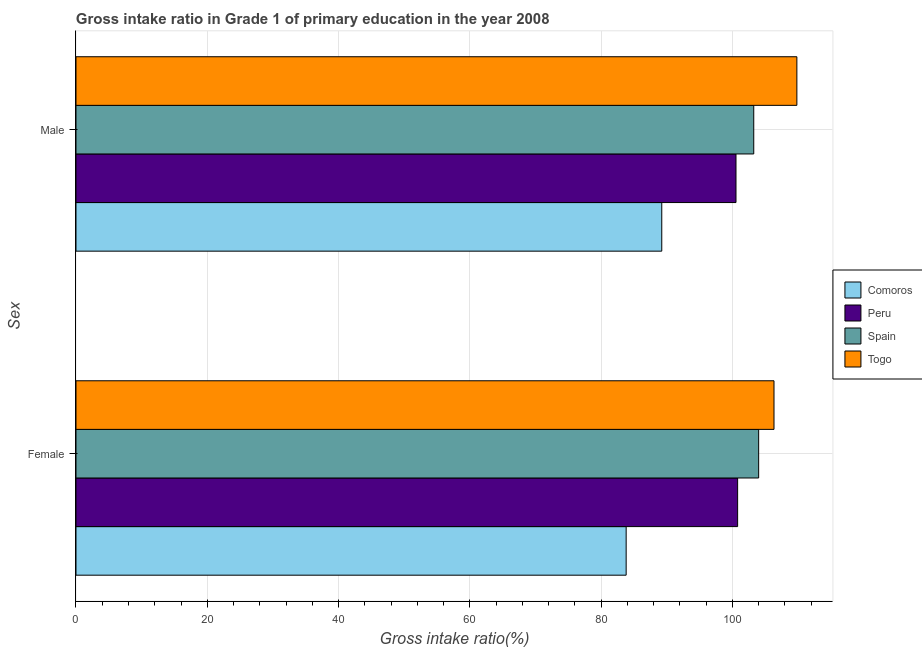How many bars are there on the 1st tick from the bottom?
Provide a short and direct response. 4. What is the gross intake ratio(female) in Spain?
Your answer should be very brief. 104.01. Across all countries, what is the maximum gross intake ratio(female)?
Offer a very short reply. 106.35. Across all countries, what is the minimum gross intake ratio(female)?
Your response must be concise. 83.82. In which country was the gross intake ratio(female) maximum?
Provide a short and direct response. Togo. In which country was the gross intake ratio(female) minimum?
Offer a terse response. Comoros. What is the total gross intake ratio(female) in the graph?
Keep it short and to the point. 394.97. What is the difference between the gross intake ratio(male) in Peru and that in Spain?
Your answer should be compact. -2.71. What is the difference between the gross intake ratio(male) in Peru and the gross intake ratio(female) in Togo?
Make the answer very short. -5.79. What is the average gross intake ratio(male) per country?
Provide a succinct answer. 100.72. What is the difference between the gross intake ratio(male) and gross intake ratio(female) in Peru?
Keep it short and to the point. -0.25. What is the ratio of the gross intake ratio(male) in Comoros to that in Togo?
Give a very brief answer. 0.81. Is the gross intake ratio(male) in Comoros less than that in Peru?
Your response must be concise. Yes. In how many countries, is the gross intake ratio(male) greater than the average gross intake ratio(male) taken over all countries?
Your answer should be compact. 2. What does the 1st bar from the bottom in Male represents?
Keep it short and to the point. Comoros. How many bars are there?
Provide a short and direct response. 8. Are all the bars in the graph horizontal?
Make the answer very short. Yes. How many countries are there in the graph?
Make the answer very short. 4. Does the graph contain any zero values?
Ensure brevity in your answer.  No. Does the graph contain grids?
Offer a terse response. Yes. How many legend labels are there?
Keep it short and to the point. 4. What is the title of the graph?
Offer a very short reply. Gross intake ratio in Grade 1 of primary education in the year 2008. What is the label or title of the X-axis?
Ensure brevity in your answer.  Gross intake ratio(%). What is the label or title of the Y-axis?
Provide a succinct answer. Sex. What is the Gross intake ratio(%) in Comoros in Female?
Your answer should be very brief. 83.82. What is the Gross intake ratio(%) of Peru in Female?
Provide a short and direct response. 100.8. What is the Gross intake ratio(%) of Spain in Female?
Ensure brevity in your answer.  104.01. What is the Gross intake ratio(%) in Togo in Female?
Offer a terse response. 106.35. What is the Gross intake ratio(%) in Comoros in Male?
Provide a succinct answer. 89.24. What is the Gross intake ratio(%) of Peru in Male?
Make the answer very short. 100.55. What is the Gross intake ratio(%) in Spain in Male?
Give a very brief answer. 103.26. What is the Gross intake ratio(%) of Togo in Male?
Ensure brevity in your answer.  109.83. Across all Sex, what is the maximum Gross intake ratio(%) of Comoros?
Make the answer very short. 89.24. Across all Sex, what is the maximum Gross intake ratio(%) in Peru?
Your response must be concise. 100.8. Across all Sex, what is the maximum Gross intake ratio(%) in Spain?
Ensure brevity in your answer.  104.01. Across all Sex, what is the maximum Gross intake ratio(%) in Togo?
Give a very brief answer. 109.83. Across all Sex, what is the minimum Gross intake ratio(%) of Comoros?
Your answer should be very brief. 83.82. Across all Sex, what is the minimum Gross intake ratio(%) of Peru?
Your response must be concise. 100.55. Across all Sex, what is the minimum Gross intake ratio(%) of Spain?
Your response must be concise. 103.26. Across all Sex, what is the minimum Gross intake ratio(%) of Togo?
Offer a very short reply. 106.35. What is the total Gross intake ratio(%) in Comoros in the graph?
Ensure brevity in your answer.  173.07. What is the total Gross intake ratio(%) of Peru in the graph?
Offer a terse response. 201.36. What is the total Gross intake ratio(%) of Spain in the graph?
Offer a terse response. 207.27. What is the total Gross intake ratio(%) in Togo in the graph?
Give a very brief answer. 216.17. What is the difference between the Gross intake ratio(%) of Comoros in Female and that in Male?
Give a very brief answer. -5.42. What is the difference between the Gross intake ratio(%) in Peru in Female and that in Male?
Offer a terse response. 0.25. What is the difference between the Gross intake ratio(%) in Spain in Female and that in Male?
Keep it short and to the point. 0.75. What is the difference between the Gross intake ratio(%) in Togo in Female and that in Male?
Your answer should be compact. -3.48. What is the difference between the Gross intake ratio(%) in Comoros in Female and the Gross intake ratio(%) in Peru in Male?
Provide a succinct answer. -16.73. What is the difference between the Gross intake ratio(%) of Comoros in Female and the Gross intake ratio(%) of Spain in Male?
Make the answer very short. -19.44. What is the difference between the Gross intake ratio(%) in Comoros in Female and the Gross intake ratio(%) in Togo in Male?
Your answer should be compact. -26.01. What is the difference between the Gross intake ratio(%) in Peru in Female and the Gross intake ratio(%) in Spain in Male?
Give a very brief answer. -2.46. What is the difference between the Gross intake ratio(%) in Peru in Female and the Gross intake ratio(%) in Togo in Male?
Your answer should be compact. -9.03. What is the difference between the Gross intake ratio(%) of Spain in Female and the Gross intake ratio(%) of Togo in Male?
Make the answer very short. -5.82. What is the average Gross intake ratio(%) of Comoros per Sex?
Keep it short and to the point. 86.53. What is the average Gross intake ratio(%) of Peru per Sex?
Ensure brevity in your answer.  100.68. What is the average Gross intake ratio(%) of Spain per Sex?
Your answer should be very brief. 103.63. What is the average Gross intake ratio(%) in Togo per Sex?
Provide a short and direct response. 108.09. What is the difference between the Gross intake ratio(%) of Comoros and Gross intake ratio(%) of Peru in Female?
Offer a terse response. -16.98. What is the difference between the Gross intake ratio(%) of Comoros and Gross intake ratio(%) of Spain in Female?
Give a very brief answer. -20.19. What is the difference between the Gross intake ratio(%) in Comoros and Gross intake ratio(%) in Togo in Female?
Provide a succinct answer. -22.52. What is the difference between the Gross intake ratio(%) of Peru and Gross intake ratio(%) of Spain in Female?
Offer a terse response. -3.21. What is the difference between the Gross intake ratio(%) in Peru and Gross intake ratio(%) in Togo in Female?
Your answer should be compact. -5.54. What is the difference between the Gross intake ratio(%) of Spain and Gross intake ratio(%) of Togo in Female?
Offer a terse response. -2.34. What is the difference between the Gross intake ratio(%) in Comoros and Gross intake ratio(%) in Peru in Male?
Provide a short and direct response. -11.31. What is the difference between the Gross intake ratio(%) of Comoros and Gross intake ratio(%) of Spain in Male?
Ensure brevity in your answer.  -14.02. What is the difference between the Gross intake ratio(%) of Comoros and Gross intake ratio(%) of Togo in Male?
Your answer should be very brief. -20.58. What is the difference between the Gross intake ratio(%) of Peru and Gross intake ratio(%) of Spain in Male?
Provide a succinct answer. -2.71. What is the difference between the Gross intake ratio(%) in Peru and Gross intake ratio(%) in Togo in Male?
Your response must be concise. -9.27. What is the difference between the Gross intake ratio(%) of Spain and Gross intake ratio(%) of Togo in Male?
Your answer should be very brief. -6.57. What is the ratio of the Gross intake ratio(%) in Comoros in Female to that in Male?
Make the answer very short. 0.94. What is the ratio of the Gross intake ratio(%) in Peru in Female to that in Male?
Offer a terse response. 1. What is the ratio of the Gross intake ratio(%) of Spain in Female to that in Male?
Your answer should be compact. 1.01. What is the ratio of the Gross intake ratio(%) in Togo in Female to that in Male?
Your answer should be very brief. 0.97. What is the difference between the highest and the second highest Gross intake ratio(%) in Comoros?
Provide a succinct answer. 5.42. What is the difference between the highest and the second highest Gross intake ratio(%) in Peru?
Provide a succinct answer. 0.25. What is the difference between the highest and the second highest Gross intake ratio(%) of Spain?
Ensure brevity in your answer.  0.75. What is the difference between the highest and the second highest Gross intake ratio(%) in Togo?
Offer a very short reply. 3.48. What is the difference between the highest and the lowest Gross intake ratio(%) in Comoros?
Provide a short and direct response. 5.42. What is the difference between the highest and the lowest Gross intake ratio(%) of Peru?
Give a very brief answer. 0.25. What is the difference between the highest and the lowest Gross intake ratio(%) of Spain?
Your answer should be very brief. 0.75. What is the difference between the highest and the lowest Gross intake ratio(%) of Togo?
Offer a very short reply. 3.48. 